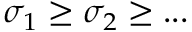<formula> <loc_0><loc_0><loc_500><loc_500>\sigma _ { 1 } \geq \sigma _ { 2 } \geq \dots</formula> 